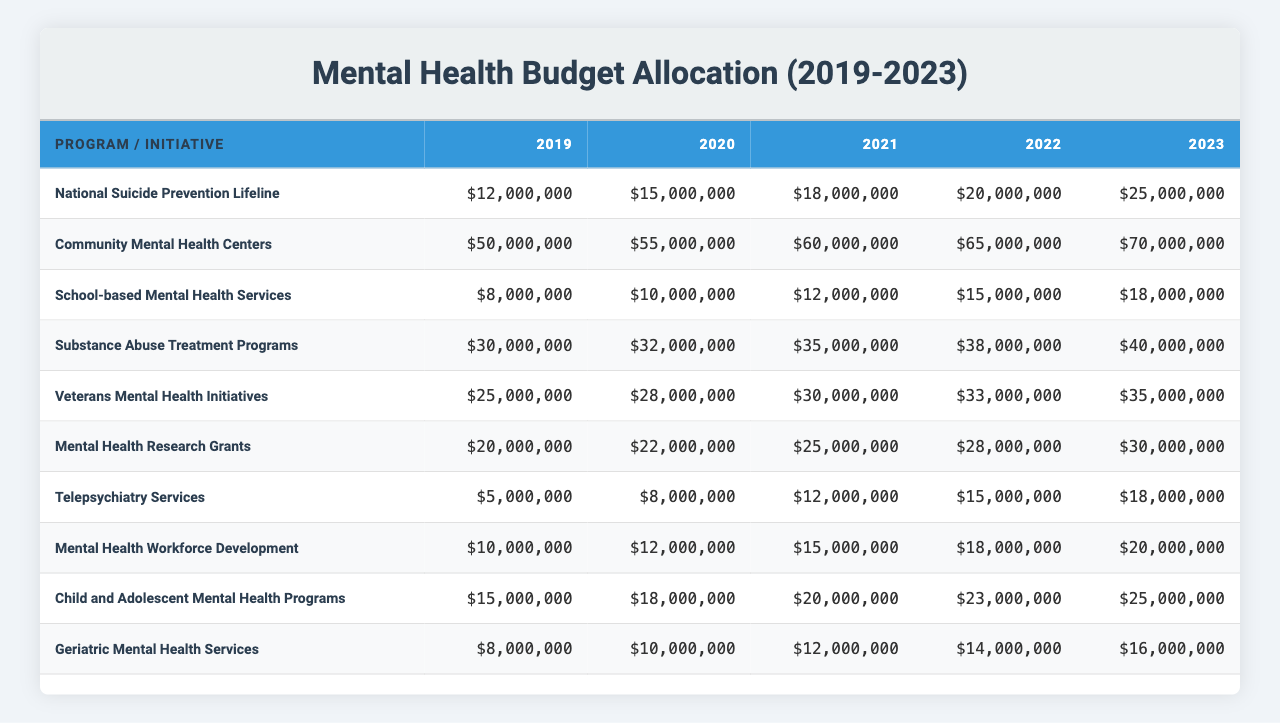What was the budget for Community Mental Health Centers in 2022? According to the table, the budget for Community Mental Health Centers in 2022 is listed directly as $65,000,000.
Answer: $65,000,000 Which program had the highest budget in 2023? By comparing the values for each program in 2023, the highest budget is for Community Mental Health Centers at $70,000,000.
Answer: Community Mental Health Centers What is the total budget allocated to Substance Abuse Treatment Programs over the 5 years? To calculate the total, sum the budgets for Substance Abuse Treatment Programs from 2019 to 2023: $30,000,000 + $32,000,000 + $35,000,000 + $38,000,000 + $40,000,000 = $175,000,000.
Answer: $175,000,000 Was there an increase in the budget for Telepsychiatry Services from 2019 to 2023? By evaluating the budget values for Telepsychiatry Services, it can be seen that it increased from $5,000,000 in 2019 to $18,000,000 in 2023. Thus, there was an increase.
Answer: Yes What is the average budget for Veterans Mental Health Initiatives over the past 5 years? To calculate the average, sum the budgets for Veterans Mental Health Initiatives for the years 2019 to 2023: $25,000,000 + $28,000,000 + $30,000,000 + $33,000,000 + $35,000,000 = $151,000,000. Then, divide by the number of years: $151,000,000 / 5 = $30,200,000.
Answer: $30,200,000 Did the budget for School-based Mental Health Services exceed $10,000,000 in every year? Looking through the budget values, School-based Mental Health Services consistently had budgets above $10,000,000 since 2020 (it was $8,000,000 in 2019). Therefore, it didn't exceed $10,000,000 in 2019.
Answer: No Which program had the smallest budget allocation in 2019? When reviewing the budgets for each program in 2019, the program with the smallest allocation is Telepsychiatry Services at $5,000,000.
Answer: Telepsychiatry Services By how much did the budget for Child and Adolescent Mental Health Programs increase from 2021 to 2022? The budget for Child and Adolescent Mental Health Programs was $20,000,000 in 2021 and increased to $23,000,000 in 2022. The increase is calculated as $23,000,000 - $20,000,000 = $3,000,000.
Answer: $3,000,000 What is the difference in budget allocation for Geriatric Mental Health Services between 2019 and 2023? The budget for Geriatric Mental Health Services in 2019 was $8,000,000 and in 2023 it was $16,000,000. The difference is $16,000,000 - $8,000,000 = $8,000,000.
Answer: $8,000,000 What was the total allocation for Mental Health Research Grants in 2021? The budget for Mental Health Research Grants in 2021 is stated directly in the table as $25,000,000.
Answer: $25,000,000 